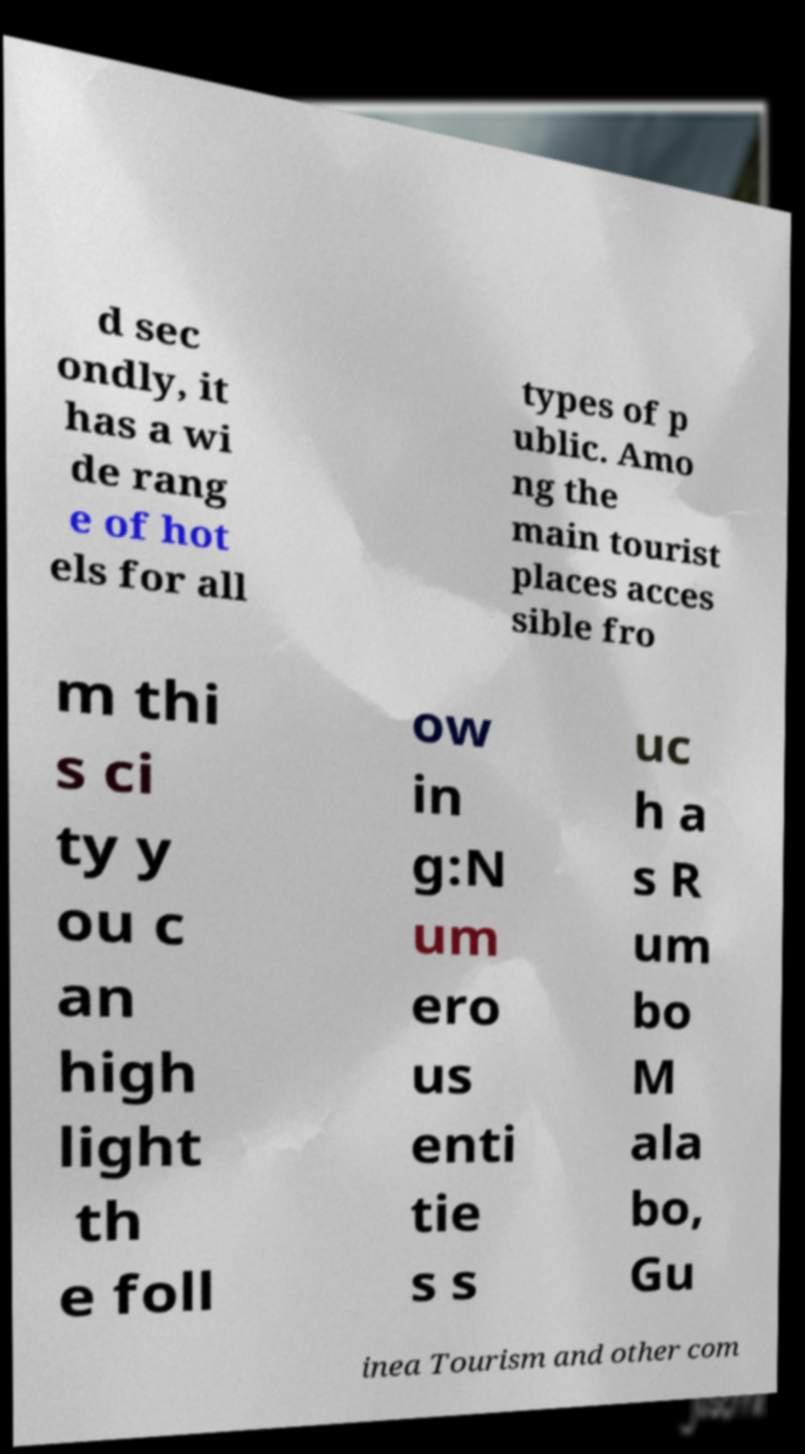Can you read and provide the text displayed in the image?This photo seems to have some interesting text. Can you extract and type it out for me? d sec ondly, it has a wi de rang e of hot els for all types of p ublic. Amo ng the main tourist places acces sible fro m thi s ci ty y ou c an high light th e foll ow in g:N um ero us enti tie s s uc h a s R um bo M ala bo, Gu inea Tourism and other com 